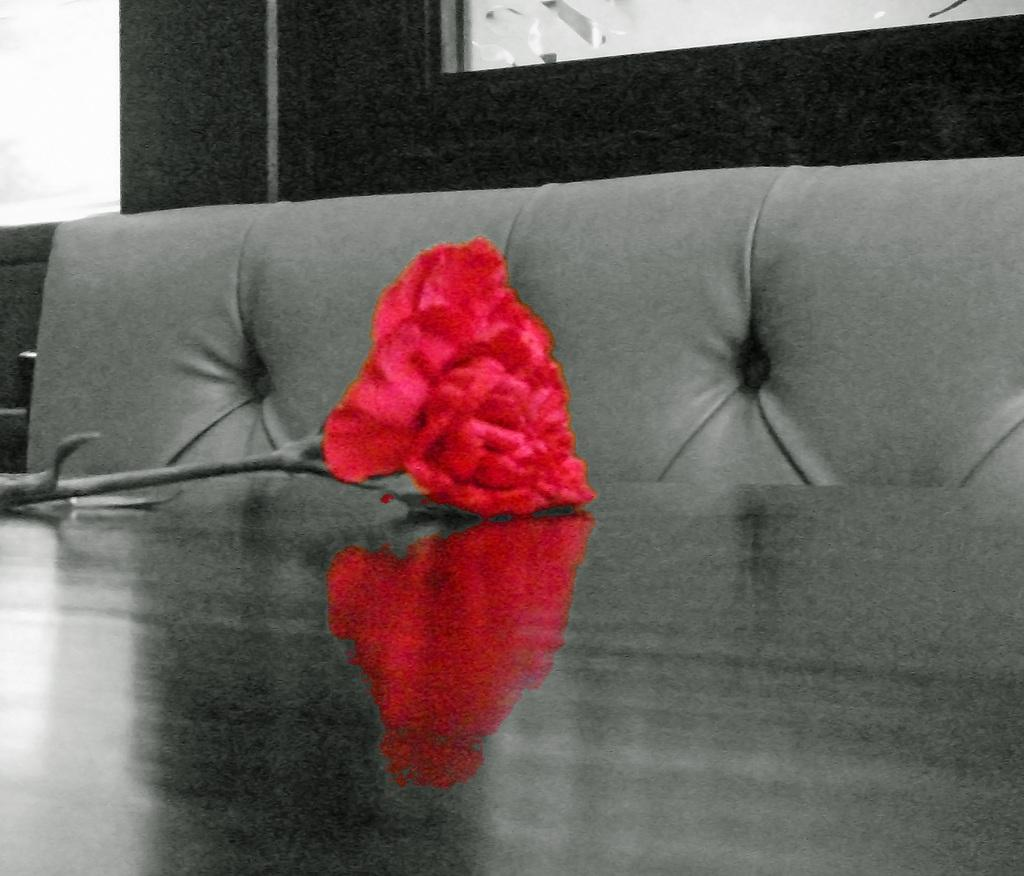What type of furniture is present in the image? There is a table and a sofa in the image. What can be seen on the table in the image? There is a red color rose on the table. Can you see a robin sitting on the sofa in the image? There is no robin present in the image. Is there an actor sitting on the sofa in the image? There is no actor present in the image. 